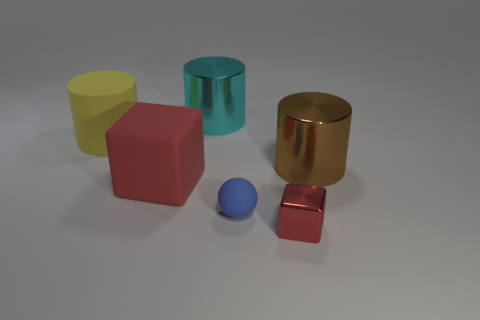Add 4 large purple matte blocks. How many objects exist? 10 Subtract all blocks. How many objects are left? 4 Add 3 large things. How many large things are left? 7 Add 6 large rubber objects. How many large rubber objects exist? 8 Subtract 2 red blocks. How many objects are left? 4 Subtract all large red blocks. Subtract all small blue spheres. How many objects are left? 4 